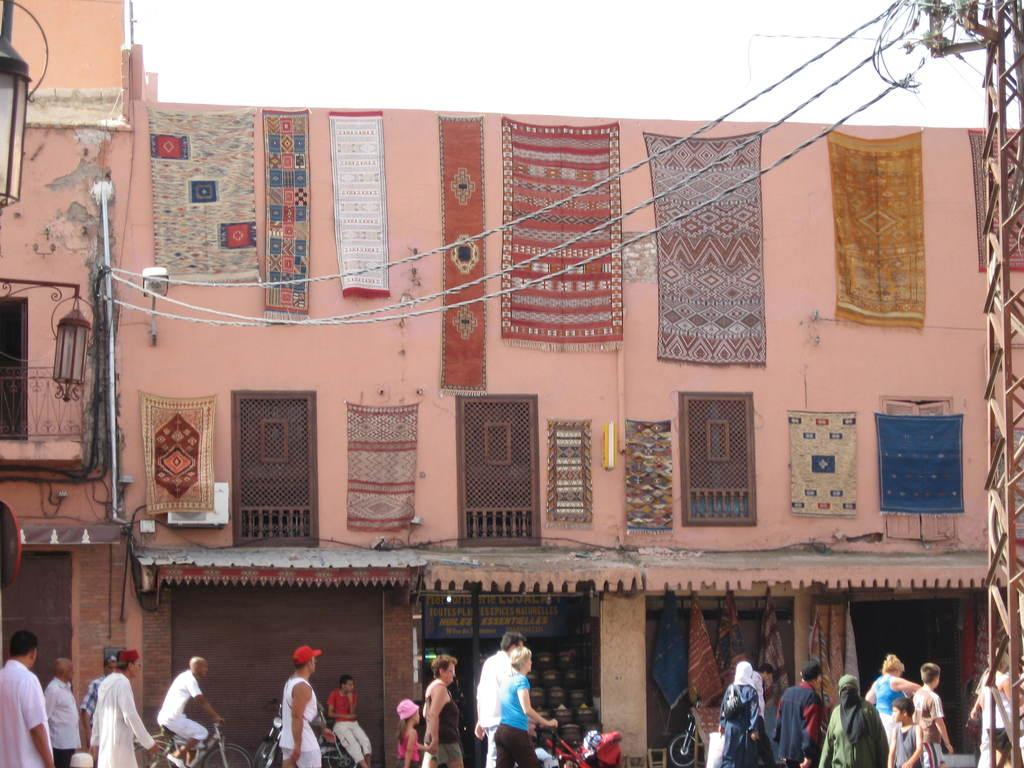What is the main structure in the image? There is a building in the image. What is hanging on the building? Colorful clothes are hanging on the building. What activity can be seen in front of the building? People are walking in front of the building. What type of property is listed on the page in the image? There is no page or property listed in the image; it features a building with colorful clothes hanging on it and people walking in front of it. 